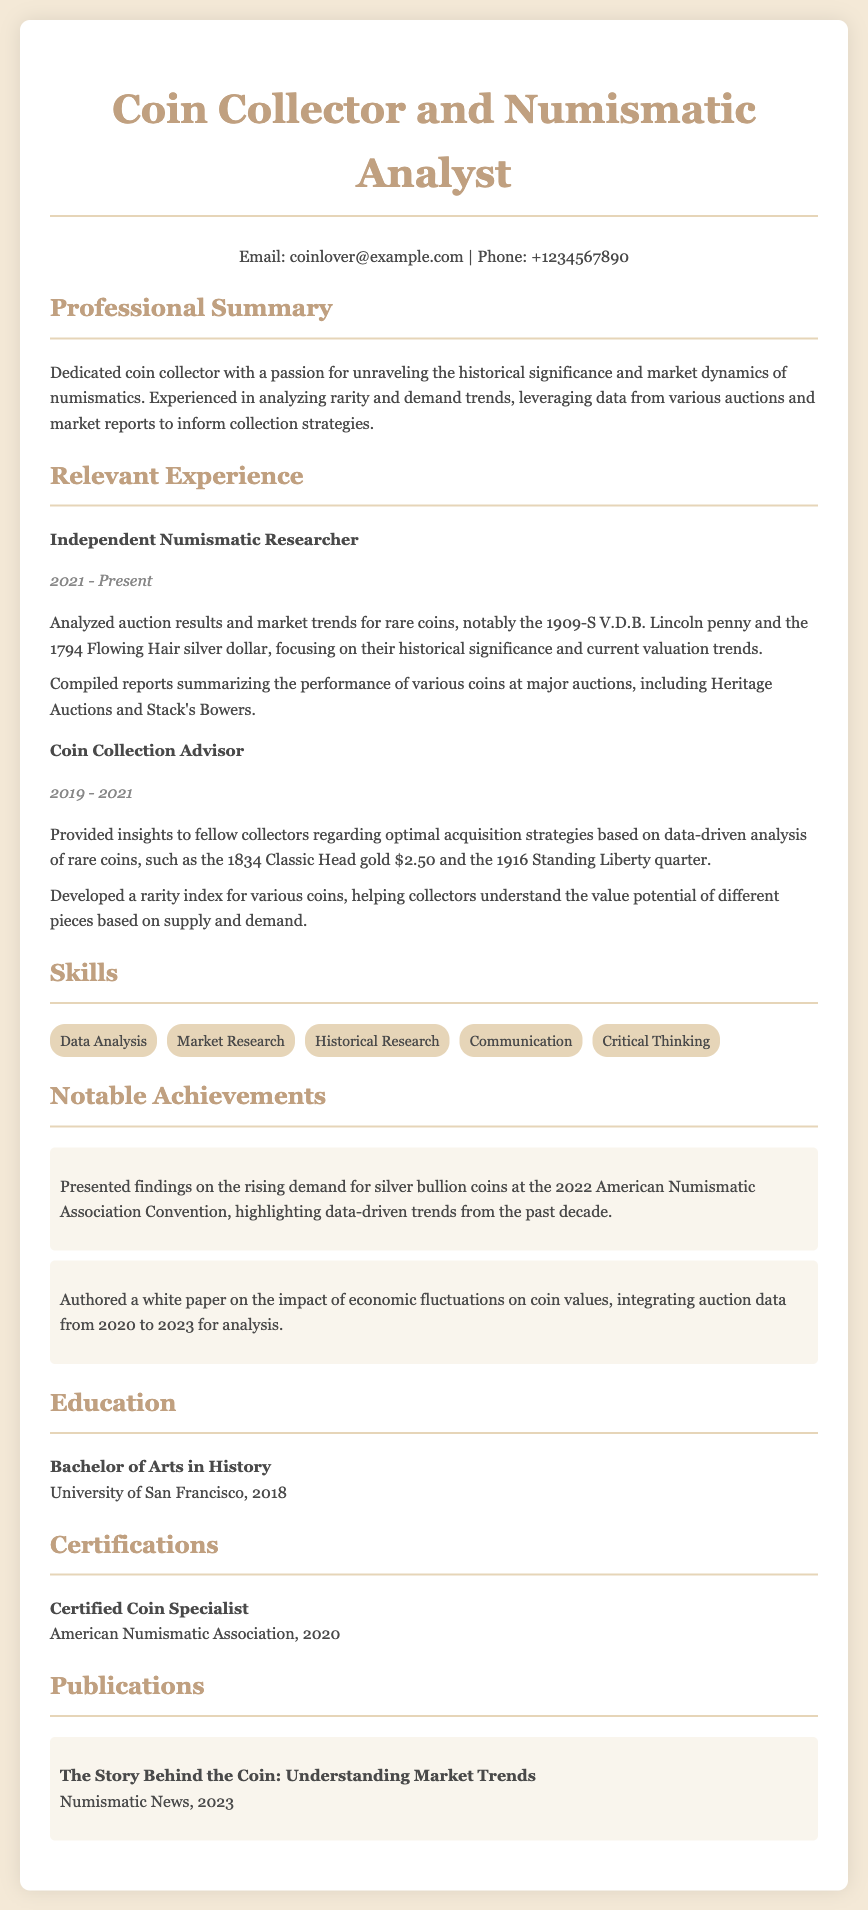what is the title of the CV? The title is specified at the top of the document as "Coin Collector and Numismatic Analyst".
Answer: Coin Collector and Numismatic Analyst who authored the publication titled "The Story Behind the Coin: Understanding Market Trends"? The author's name is typically associated with the publication, which in this case is indicated as being part of "Numismatic News".
Answer: Numismatic News what year did the author receive their Bachelor's degree? The educational background specifies that the degree was obtained in 2018.
Answer: 2018 how many major roles are listed under Relevant Experience? The document lists two major roles under Relevant Experience: Independent Numismatic Researcher and Coin Collection Advisor.
Answer: 2 what skill is explicitly mentioned as related to market research? The skills section lists "Market Research" as one of the skills.
Answer: Market Research in which year was the author certified as a coin specialist? The certification year for being a coin specialist is 2020.
Answer: 2020 what is the duration of the Independent Numismatic Researcher role? The role of Independent Numismatic Researcher lasted from 2021 to Present.
Answer: 2021 - Present what significant presentation did the author give in 2022? The author presented findings on "the rising demand for silver bullion coins" at a major event.
Answer: the rising demand for silver bullion coins what institution issued the certification for coin specialists? The certification for coin specialists was issued by the American Numismatic Association.
Answer: American Numismatic Association 